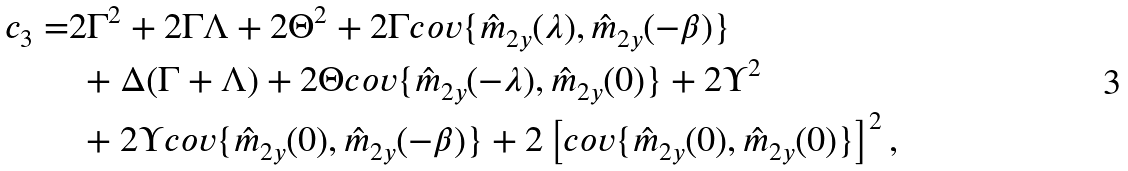Convert formula to latex. <formula><loc_0><loc_0><loc_500><loc_500>c _ { 3 } = & 2 \Gamma ^ { 2 } + 2 \Gamma \Lambda + 2 \Theta ^ { 2 } + 2 \Gamma c o v \{ \hat { m } _ { 2 y } ( \lambda ) , \hat { m } _ { 2 y } ( - \beta ) \} \\ & \ + \Delta ( \Gamma + \Lambda ) + 2 \Theta c o v \{ \hat { m } _ { 2 y } ( - \lambda ) , \hat { m } _ { 2 y } ( 0 ) \} + 2 \Upsilon ^ { 2 } \\ & \ + 2 \Upsilon c o v \{ \hat { m } _ { 2 y } ( 0 ) , \hat { m } _ { 2 y } ( - \beta ) \} + 2 \left [ c o v \{ \hat { m } _ { 2 y } ( 0 ) , \hat { m } _ { 2 y } ( 0 ) \} \right ] ^ { 2 } ,</formula> 